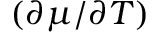<formula> <loc_0><loc_0><loc_500><loc_500>( \partial \mu / \partial T )</formula> 